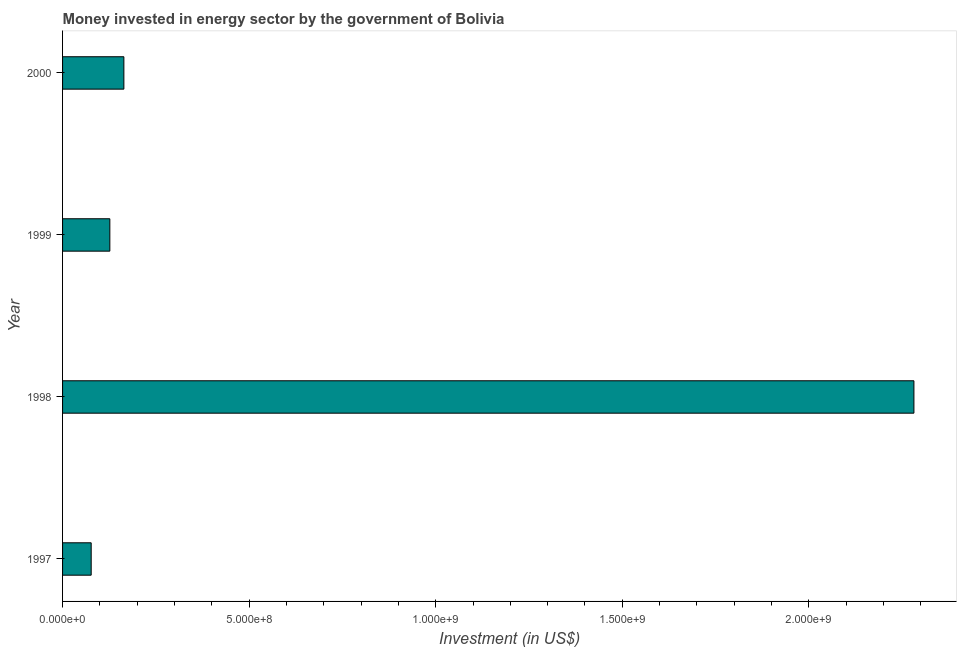Does the graph contain any zero values?
Offer a terse response. No. What is the title of the graph?
Your response must be concise. Money invested in energy sector by the government of Bolivia. What is the label or title of the X-axis?
Provide a short and direct response. Investment (in US$). What is the label or title of the Y-axis?
Keep it short and to the point. Year. What is the investment in energy in 1999?
Offer a very short reply. 1.27e+08. Across all years, what is the maximum investment in energy?
Provide a succinct answer. 2.28e+09. Across all years, what is the minimum investment in energy?
Offer a terse response. 7.67e+07. In which year was the investment in energy minimum?
Your answer should be very brief. 1997. What is the sum of the investment in energy?
Provide a succinct answer. 2.65e+09. What is the difference between the investment in energy in 1997 and 1998?
Your answer should be very brief. -2.20e+09. What is the average investment in energy per year?
Provide a short and direct response. 6.62e+08. What is the median investment in energy?
Make the answer very short. 1.46e+08. In how many years, is the investment in energy greater than 400000000 US$?
Make the answer very short. 1. What is the ratio of the investment in energy in 1998 to that in 2000?
Ensure brevity in your answer.  13.89. Is the investment in energy in 1999 less than that in 2000?
Your answer should be compact. Yes. Is the difference between the investment in energy in 1999 and 2000 greater than the difference between any two years?
Provide a short and direct response. No. What is the difference between the highest and the second highest investment in energy?
Provide a short and direct response. 2.12e+09. Is the sum of the investment in energy in 1999 and 2000 greater than the maximum investment in energy across all years?
Your answer should be very brief. No. What is the difference between the highest and the lowest investment in energy?
Provide a succinct answer. 2.20e+09. In how many years, is the investment in energy greater than the average investment in energy taken over all years?
Your answer should be compact. 1. Are all the bars in the graph horizontal?
Offer a very short reply. Yes. How many years are there in the graph?
Provide a short and direct response. 4. What is the Investment (in US$) in 1997?
Your answer should be very brief. 7.67e+07. What is the Investment (in US$) of 1998?
Your response must be concise. 2.28e+09. What is the Investment (in US$) of 1999?
Your answer should be compact. 1.27e+08. What is the Investment (in US$) of 2000?
Ensure brevity in your answer.  1.64e+08. What is the difference between the Investment (in US$) in 1997 and 1998?
Provide a succinct answer. -2.20e+09. What is the difference between the Investment (in US$) in 1997 and 1999?
Offer a terse response. -5.00e+07. What is the difference between the Investment (in US$) in 1997 and 2000?
Offer a very short reply. -8.76e+07. What is the difference between the Investment (in US$) in 1998 and 1999?
Provide a succinct answer. 2.15e+09. What is the difference between the Investment (in US$) in 1998 and 2000?
Your answer should be compact. 2.12e+09. What is the difference between the Investment (in US$) in 1999 and 2000?
Provide a short and direct response. -3.76e+07. What is the ratio of the Investment (in US$) in 1997 to that in 1998?
Offer a terse response. 0.03. What is the ratio of the Investment (in US$) in 1997 to that in 1999?
Your answer should be compact. 0.6. What is the ratio of the Investment (in US$) in 1997 to that in 2000?
Keep it short and to the point. 0.47. What is the ratio of the Investment (in US$) in 1998 to that in 1999?
Your answer should be compact. 18.01. What is the ratio of the Investment (in US$) in 1998 to that in 2000?
Give a very brief answer. 13.89. What is the ratio of the Investment (in US$) in 1999 to that in 2000?
Your answer should be very brief. 0.77. 